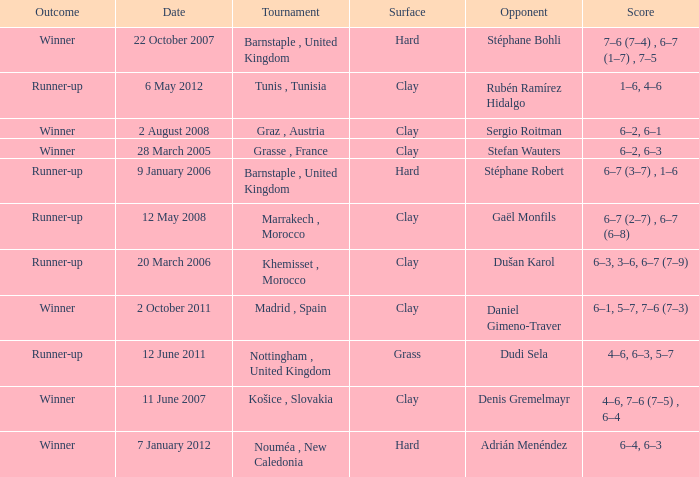What is the score on 2 October 2011? 6–1, 5–7, 7–6 (7–3). 